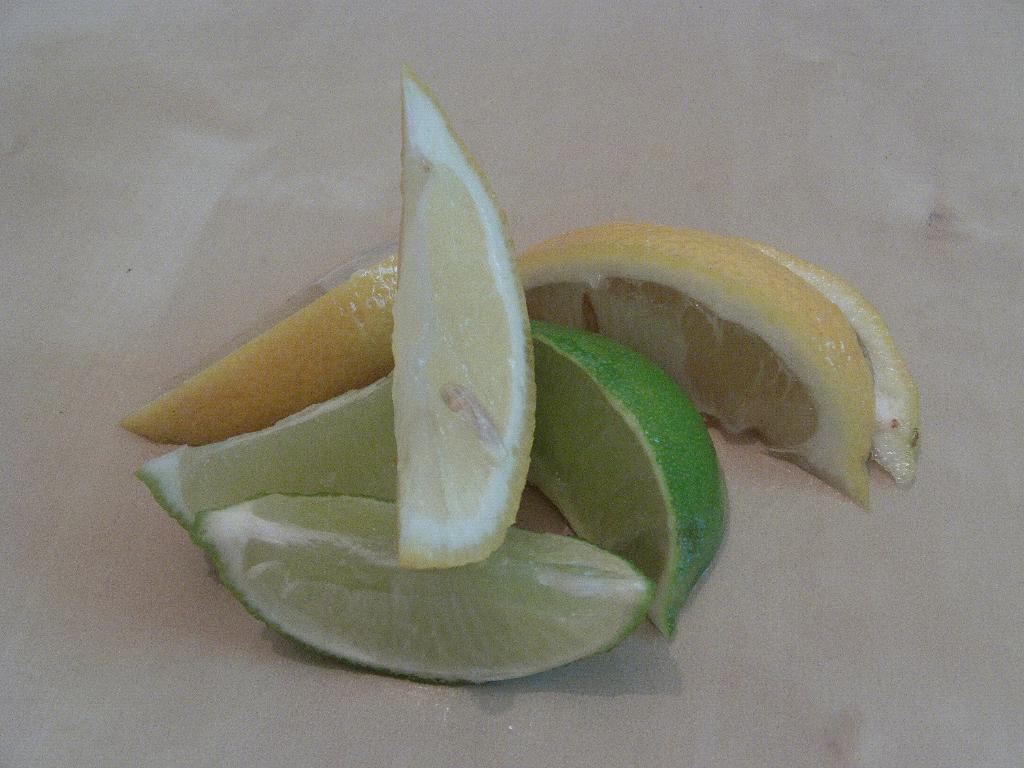How would you summarize this image in a sentence or two? In the center of the image we can see one table. On the table,we can see orange slices. 